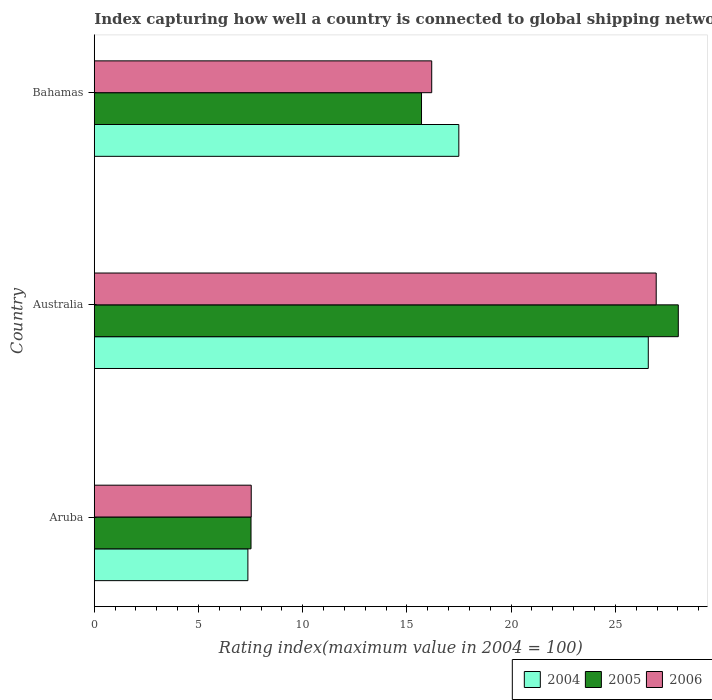How many different coloured bars are there?
Keep it short and to the point. 3. How many groups of bars are there?
Offer a very short reply. 3. What is the label of the 2nd group of bars from the top?
Keep it short and to the point. Australia. In how many cases, is the number of bars for a given country not equal to the number of legend labels?
Provide a short and direct response. 0. What is the rating index in 2006 in Bahamas?
Keep it short and to the point. 16.19. Across all countries, what is the maximum rating index in 2006?
Keep it short and to the point. 26.96. Across all countries, what is the minimum rating index in 2004?
Offer a very short reply. 7.37. In which country was the rating index in 2006 maximum?
Your answer should be very brief. Australia. In which country was the rating index in 2005 minimum?
Ensure brevity in your answer.  Aruba. What is the total rating index in 2004 in the graph?
Offer a very short reply. 51.44. What is the difference between the rating index in 2006 in Aruba and that in Australia?
Give a very brief answer. -19.43. What is the difference between the rating index in 2004 in Bahamas and the rating index in 2006 in Aruba?
Keep it short and to the point. 9.96. What is the average rating index in 2004 per country?
Your answer should be compact. 17.15. What is the difference between the rating index in 2005 and rating index in 2006 in Aruba?
Offer a very short reply. -0.01. In how many countries, is the rating index in 2006 greater than 14 ?
Make the answer very short. 2. What is the ratio of the rating index in 2004 in Aruba to that in Bahamas?
Make the answer very short. 0.42. What is the difference between the highest and the second highest rating index in 2005?
Offer a very short reply. 12.32. What is the difference between the highest and the lowest rating index in 2006?
Provide a short and direct response. 19.43. In how many countries, is the rating index in 2006 greater than the average rating index in 2006 taken over all countries?
Your response must be concise. 1. Is the sum of the rating index in 2005 in Australia and Bahamas greater than the maximum rating index in 2006 across all countries?
Give a very brief answer. Yes. What does the 1st bar from the bottom in Australia represents?
Ensure brevity in your answer.  2004. Are all the bars in the graph horizontal?
Your answer should be very brief. Yes. Are the values on the major ticks of X-axis written in scientific E-notation?
Offer a very short reply. No. Does the graph contain any zero values?
Offer a terse response. No. Does the graph contain grids?
Your answer should be compact. No. How are the legend labels stacked?
Offer a terse response. Horizontal. What is the title of the graph?
Your answer should be very brief. Index capturing how well a country is connected to global shipping networks. Does "1968" appear as one of the legend labels in the graph?
Your response must be concise. No. What is the label or title of the X-axis?
Make the answer very short. Rating index(maximum value in 2004 = 100). What is the label or title of the Y-axis?
Your answer should be compact. Country. What is the Rating index(maximum value in 2004 = 100) of 2004 in Aruba?
Your answer should be compact. 7.37. What is the Rating index(maximum value in 2004 = 100) of 2005 in Aruba?
Offer a very short reply. 7.52. What is the Rating index(maximum value in 2004 = 100) in 2006 in Aruba?
Your answer should be very brief. 7.53. What is the Rating index(maximum value in 2004 = 100) in 2004 in Australia?
Provide a succinct answer. 26.58. What is the Rating index(maximum value in 2004 = 100) of 2005 in Australia?
Your answer should be compact. 28.02. What is the Rating index(maximum value in 2004 = 100) in 2006 in Australia?
Offer a terse response. 26.96. What is the Rating index(maximum value in 2004 = 100) of 2004 in Bahamas?
Provide a succinct answer. 17.49. What is the Rating index(maximum value in 2004 = 100) of 2006 in Bahamas?
Your response must be concise. 16.19. Across all countries, what is the maximum Rating index(maximum value in 2004 = 100) in 2004?
Offer a very short reply. 26.58. Across all countries, what is the maximum Rating index(maximum value in 2004 = 100) in 2005?
Provide a succinct answer. 28.02. Across all countries, what is the maximum Rating index(maximum value in 2004 = 100) of 2006?
Make the answer very short. 26.96. Across all countries, what is the minimum Rating index(maximum value in 2004 = 100) in 2004?
Your answer should be very brief. 7.37. Across all countries, what is the minimum Rating index(maximum value in 2004 = 100) in 2005?
Keep it short and to the point. 7.52. Across all countries, what is the minimum Rating index(maximum value in 2004 = 100) in 2006?
Offer a terse response. 7.53. What is the total Rating index(maximum value in 2004 = 100) of 2004 in the graph?
Your answer should be compact. 51.44. What is the total Rating index(maximum value in 2004 = 100) of 2005 in the graph?
Provide a short and direct response. 51.24. What is the total Rating index(maximum value in 2004 = 100) of 2006 in the graph?
Your response must be concise. 50.68. What is the difference between the Rating index(maximum value in 2004 = 100) of 2004 in Aruba and that in Australia?
Ensure brevity in your answer.  -19.21. What is the difference between the Rating index(maximum value in 2004 = 100) in 2005 in Aruba and that in Australia?
Give a very brief answer. -20.5. What is the difference between the Rating index(maximum value in 2004 = 100) in 2006 in Aruba and that in Australia?
Offer a terse response. -19.43. What is the difference between the Rating index(maximum value in 2004 = 100) of 2004 in Aruba and that in Bahamas?
Make the answer very short. -10.12. What is the difference between the Rating index(maximum value in 2004 = 100) of 2005 in Aruba and that in Bahamas?
Ensure brevity in your answer.  -8.18. What is the difference between the Rating index(maximum value in 2004 = 100) of 2006 in Aruba and that in Bahamas?
Provide a succinct answer. -8.66. What is the difference between the Rating index(maximum value in 2004 = 100) in 2004 in Australia and that in Bahamas?
Your answer should be compact. 9.09. What is the difference between the Rating index(maximum value in 2004 = 100) in 2005 in Australia and that in Bahamas?
Your response must be concise. 12.32. What is the difference between the Rating index(maximum value in 2004 = 100) in 2006 in Australia and that in Bahamas?
Provide a succinct answer. 10.77. What is the difference between the Rating index(maximum value in 2004 = 100) in 2004 in Aruba and the Rating index(maximum value in 2004 = 100) in 2005 in Australia?
Ensure brevity in your answer.  -20.65. What is the difference between the Rating index(maximum value in 2004 = 100) of 2004 in Aruba and the Rating index(maximum value in 2004 = 100) of 2006 in Australia?
Make the answer very short. -19.59. What is the difference between the Rating index(maximum value in 2004 = 100) in 2005 in Aruba and the Rating index(maximum value in 2004 = 100) in 2006 in Australia?
Offer a terse response. -19.44. What is the difference between the Rating index(maximum value in 2004 = 100) in 2004 in Aruba and the Rating index(maximum value in 2004 = 100) in 2005 in Bahamas?
Make the answer very short. -8.33. What is the difference between the Rating index(maximum value in 2004 = 100) in 2004 in Aruba and the Rating index(maximum value in 2004 = 100) in 2006 in Bahamas?
Provide a succinct answer. -8.82. What is the difference between the Rating index(maximum value in 2004 = 100) of 2005 in Aruba and the Rating index(maximum value in 2004 = 100) of 2006 in Bahamas?
Ensure brevity in your answer.  -8.67. What is the difference between the Rating index(maximum value in 2004 = 100) of 2004 in Australia and the Rating index(maximum value in 2004 = 100) of 2005 in Bahamas?
Offer a very short reply. 10.88. What is the difference between the Rating index(maximum value in 2004 = 100) in 2004 in Australia and the Rating index(maximum value in 2004 = 100) in 2006 in Bahamas?
Ensure brevity in your answer.  10.39. What is the difference between the Rating index(maximum value in 2004 = 100) of 2005 in Australia and the Rating index(maximum value in 2004 = 100) of 2006 in Bahamas?
Provide a short and direct response. 11.83. What is the average Rating index(maximum value in 2004 = 100) of 2004 per country?
Offer a very short reply. 17.15. What is the average Rating index(maximum value in 2004 = 100) of 2005 per country?
Your answer should be very brief. 17.08. What is the average Rating index(maximum value in 2004 = 100) of 2006 per country?
Give a very brief answer. 16.89. What is the difference between the Rating index(maximum value in 2004 = 100) in 2004 and Rating index(maximum value in 2004 = 100) in 2005 in Aruba?
Your response must be concise. -0.15. What is the difference between the Rating index(maximum value in 2004 = 100) in 2004 and Rating index(maximum value in 2004 = 100) in 2006 in Aruba?
Your answer should be very brief. -0.16. What is the difference between the Rating index(maximum value in 2004 = 100) of 2005 and Rating index(maximum value in 2004 = 100) of 2006 in Aruba?
Keep it short and to the point. -0.01. What is the difference between the Rating index(maximum value in 2004 = 100) of 2004 and Rating index(maximum value in 2004 = 100) of 2005 in Australia?
Keep it short and to the point. -1.44. What is the difference between the Rating index(maximum value in 2004 = 100) in 2004 and Rating index(maximum value in 2004 = 100) in 2006 in Australia?
Keep it short and to the point. -0.38. What is the difference between the Rating index(maximum value in 2004 = 100) in 2005 and Rating index(maximum value in 2004 = 100) in 2006 in Australia?
Provide a short and direct response. 1.06. What is the difference between the Rating index(maximum value in 2004 = 100) of 2004 and Rating index(maximum value in 2004 = 100) of 2005 in Bahamas?
Your response must be concise. 1.79. What is the difference between the Rating index(maximum value in 2004 = 100) of 2004 and Rating index(maximum value in 2004 = 100) of 2006 in Bahamas?
Offer a terse response. 1.3. What is the difference between the Rating index(maximum value in 2004 = 100) in 2005 and Rating index(maximum value in 2004 = 100) in 2006 in Bahamas?
Make the answer very short. -0.49. What is the ratio of the Rating index(maximum value in 2004 = 100) in 2004 in Aruba to that in Australia?
Your answer should be compact. 0.28. What is the ratio of the Rating index(maximum value in 2004 = 100) in 2005 in Aruba to that in Australia?
Ensure brevity in your answer.  0.27. What is the ratio of the Rating index(maximum value in 2004 = 100) of 2006 in Aruba to that in Australia?
Your answer should be compact. 0.28. What is the ratio of the Rating index(maximum value in 2004 = 100) of 2004 in Aruba to that in Bahamas?
Provide a short and direct response. 0.42. What is the ratio of the Rating index(maximum value in 2004 = 100) in 2005 in Aruba to that in Bahamas?
Keep it short and to the point. 0.48. What is the ratio of the Rating index(maximum value in 2004 = 100) of 2006 in Aruba to that in Bahamas?
Give a very brief answer. 0.47. What is the ratio of the Rating index(maximum value in 2004 = 100) of 2004 in Australia to that in Bahamas?
Offer a very short reply. 1.52. What is the ratio of the Rating index(maximum value in 2004 = 100) of 2005 in Australia to that in Bahamas?
Offer a terse response. 1.78. What is the ratio of the Rating index(maximum value in 2004 = 100) of 2006 in Australia to that in Bahamas?
Make the answer very short. 1.67. What is the difference between the highest and the second highest Rating index(maximum value in 2004 = 100) of 2004?
Provide a succinct answer. 9.09. What is the difference between the highest and the second highest Rating index(maximum value in 2004 = 100) in 2005?
Give a very brief answer. 12.32. What is the difference between the highest and the second highest Rating index(maximum value in 2004 = 100) in 2006?
Provide a short and direct response. 10.77. What is the difference between the highest and the lowest Rating index(maximum value in 2004 = 100) of 2004?
Give a very brief answer. 19.21. What is the difference between the highest and the lowest Rating index(maximum value in 2004 = 100) of 2005?
Your response must be concise. 20.5. What is the difference between the highest and the lowest Rating index(maximum value in 2004 = 100) of 2006?
Provide a succinct answer. 19.43. 